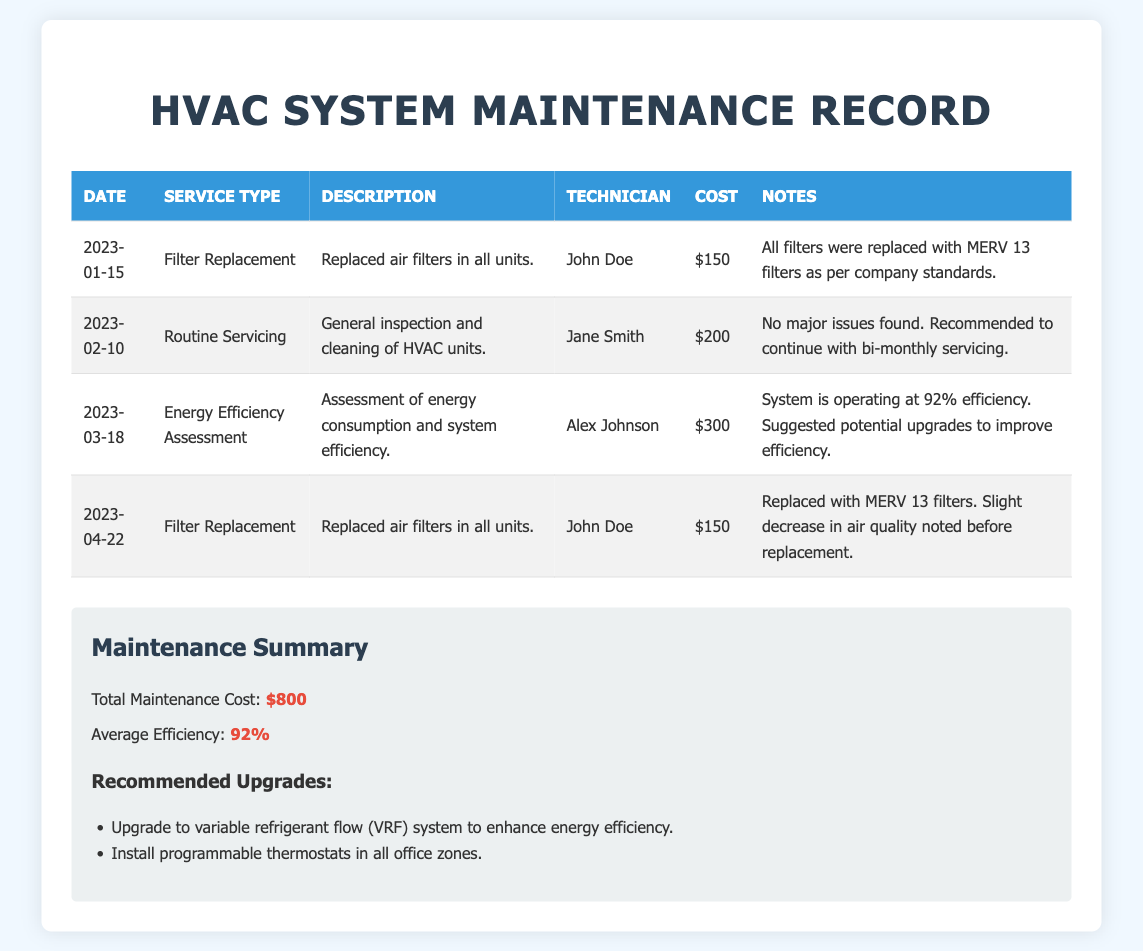What is the date of the last filter replacement? The last filter replacement was recorded on April 22, 2023.
Answer: April 22, 2023 Who performed the energy efficiency assessment? The energy efficiency assessment was conducted by Alex Johnson.
Answer: Alex Johnson How much did the routine servicing cost? The cost for the routine servicing on February 10, 2023, was $200.
Answer: $200 What is the average efficiency of the HVAC system? The average efficiency of the HVAC system is stated as 92%.
Answer: 92% What type of filters were used in the last replacement? The filters replaced on April 22, 2023, were MERV 13 filters.
Answer: MERV 13 filters What were the recommended upgrades for the HVAC system? The recommended upgrades include installing programmable thermostats and upgrading to a variable refrigerant flow (VRF) system.
Answer: Upgrade to variable refrigerant flow (VRF) system, Install programmable thermostats What is the total maintenance cost recorded? The total maintenance cost from all services listed is $800.
Answer: $800 What was found during the routine servicing? The routine servicing report indicated no major issues found.
Answer: No major issues found 